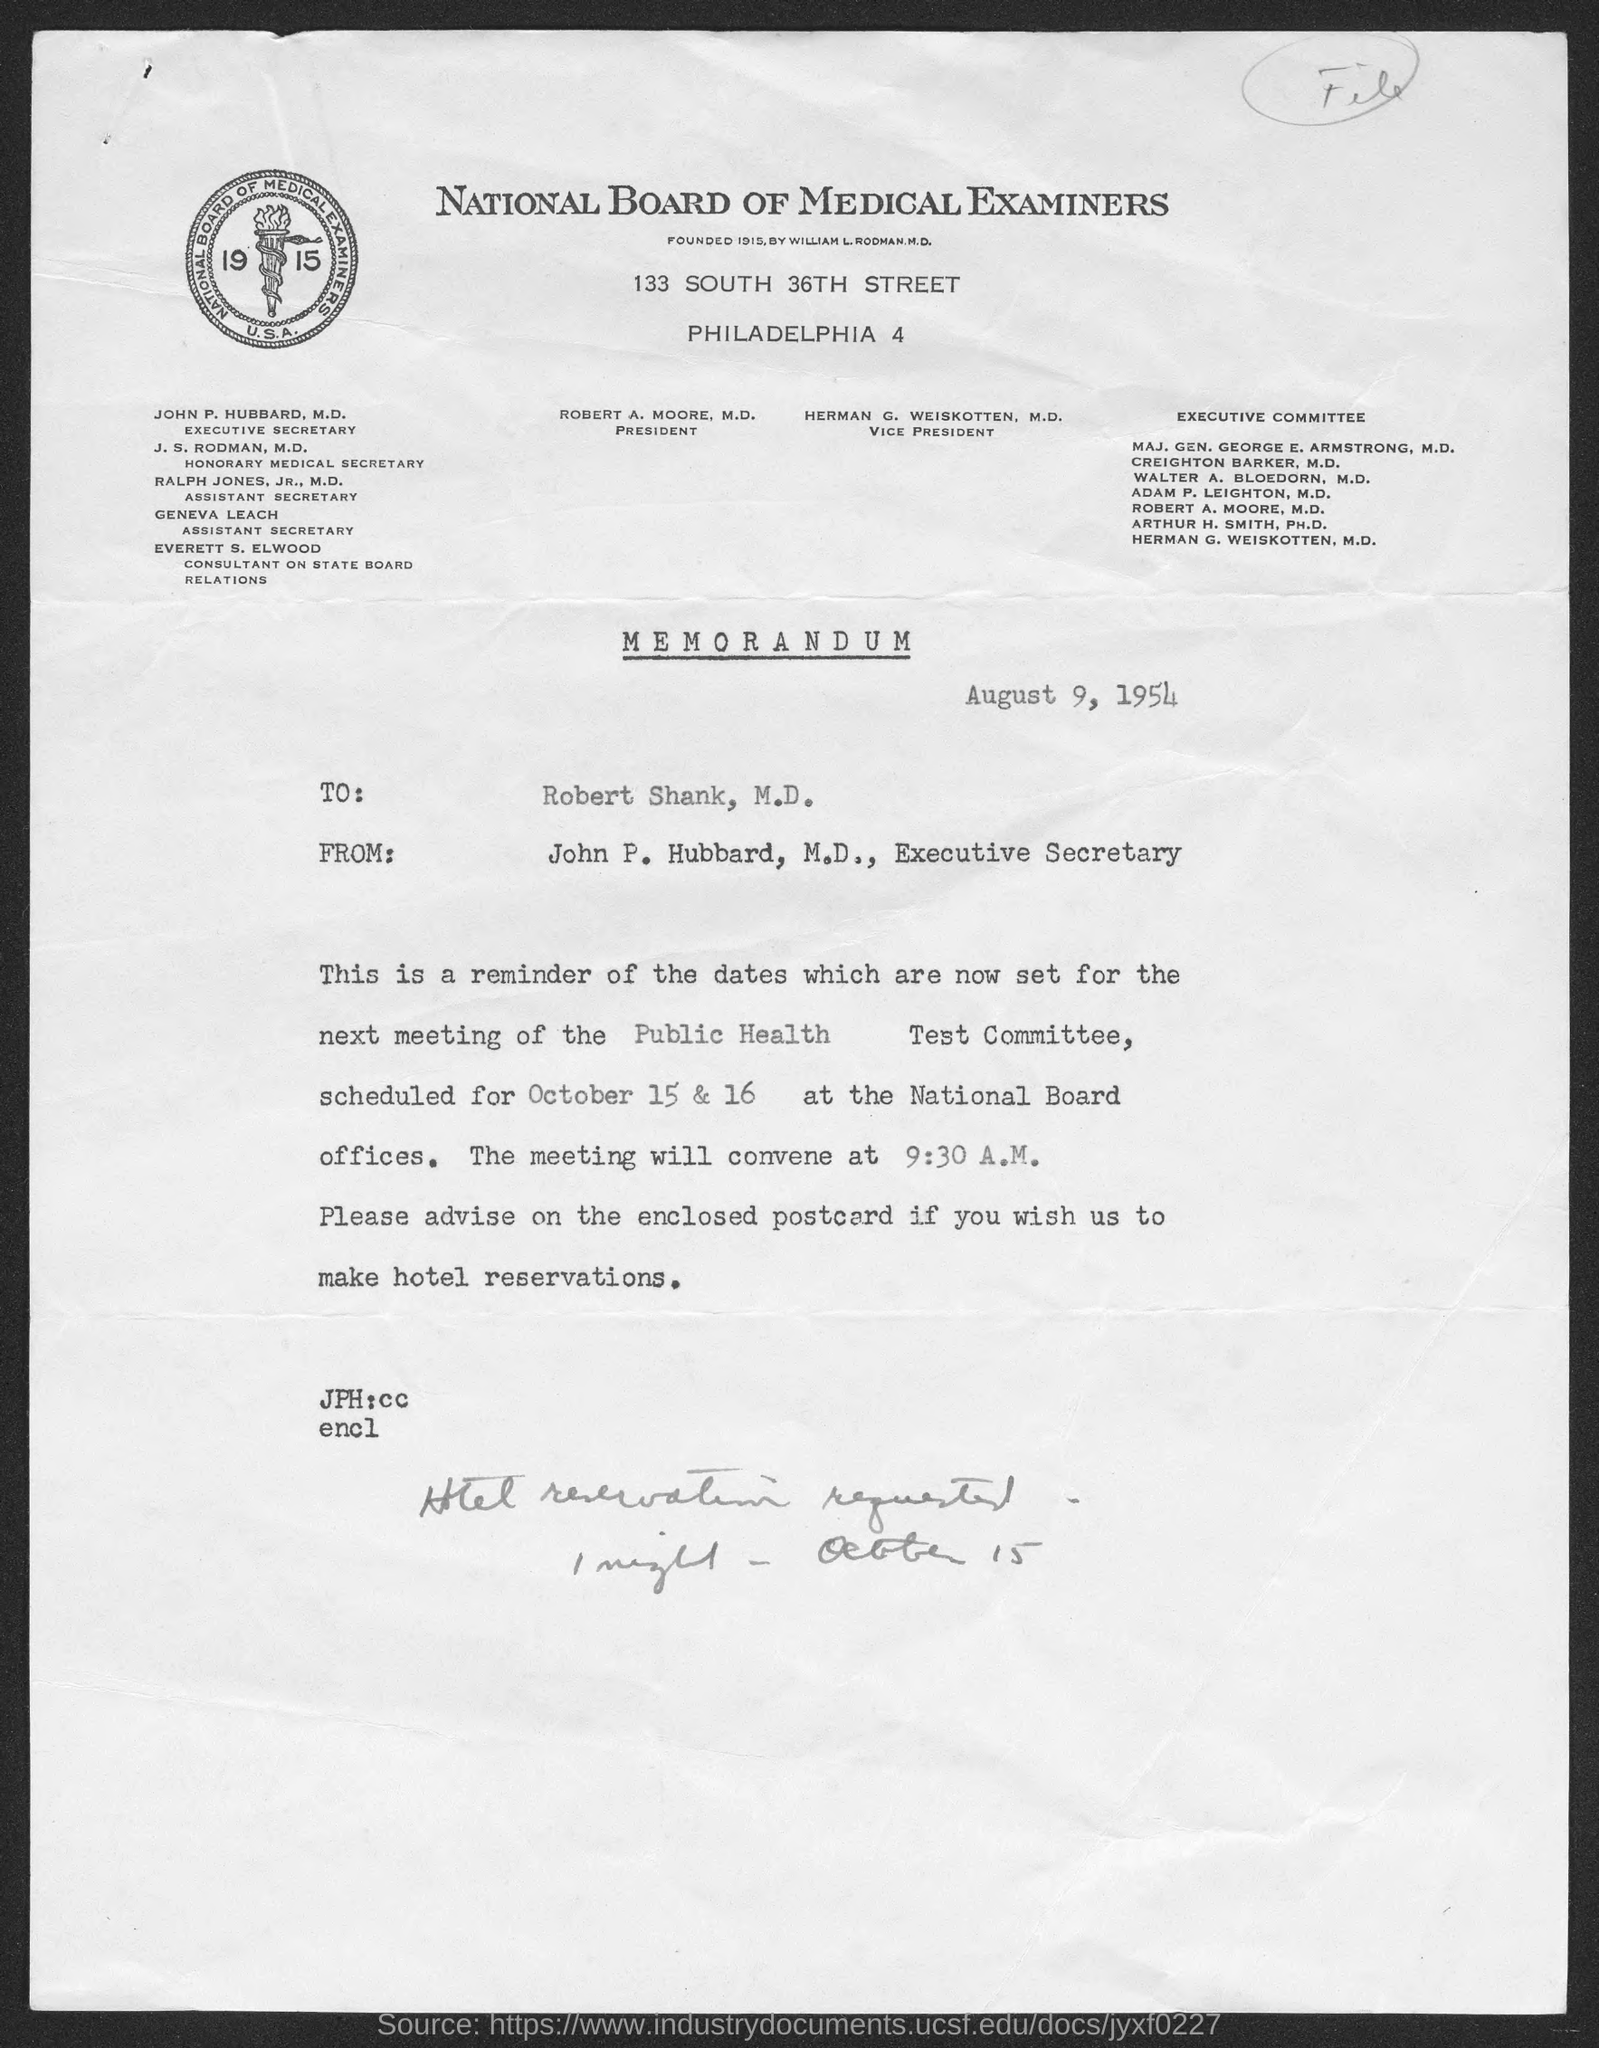Who found national board of medical examiners ?
Make the answer very short. William L. Rodman, M.D. What is the address of national board of medical examiners ?
Make the answer very short. 133 south 36th street. What is the position of robert a. moore, m.d.?
Ensure brevity in your answer.  President. What is the position of herman g. weiskotten, m.d. ?
Your answer should be compact. Vice president. What is the position of john p. hubbard, m.d. ?
Your answer should be compact. Executive secretary. What is the position of j.s. rodman, m.d. ?
Give a very brief answer. Honorary medical secretary. What is the position of ralph jones,jr., m.d.?
Keep it short and to the point. Assistant secretary. What is the position of geneva leach ?
Your answer should be compact. Assistant secretary. When is the memorandum dated?
Your response must be concise. August 9, 1954. 